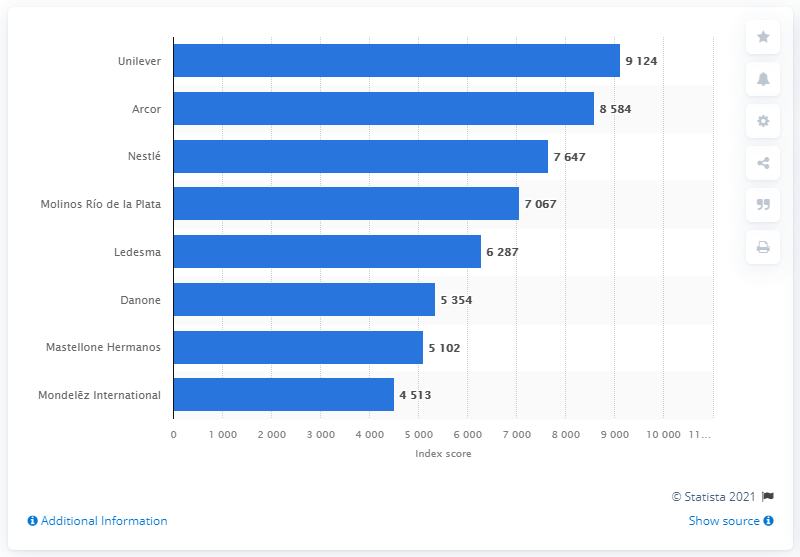Identify some key points in this picture. Unilever had the greatest capacity to attract and retain talent in Argentina, according to the data. 